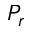Convert formula to latex. <formula><loc_0><loc_0><loc_500><loc_500>P _ { r }</formula> 